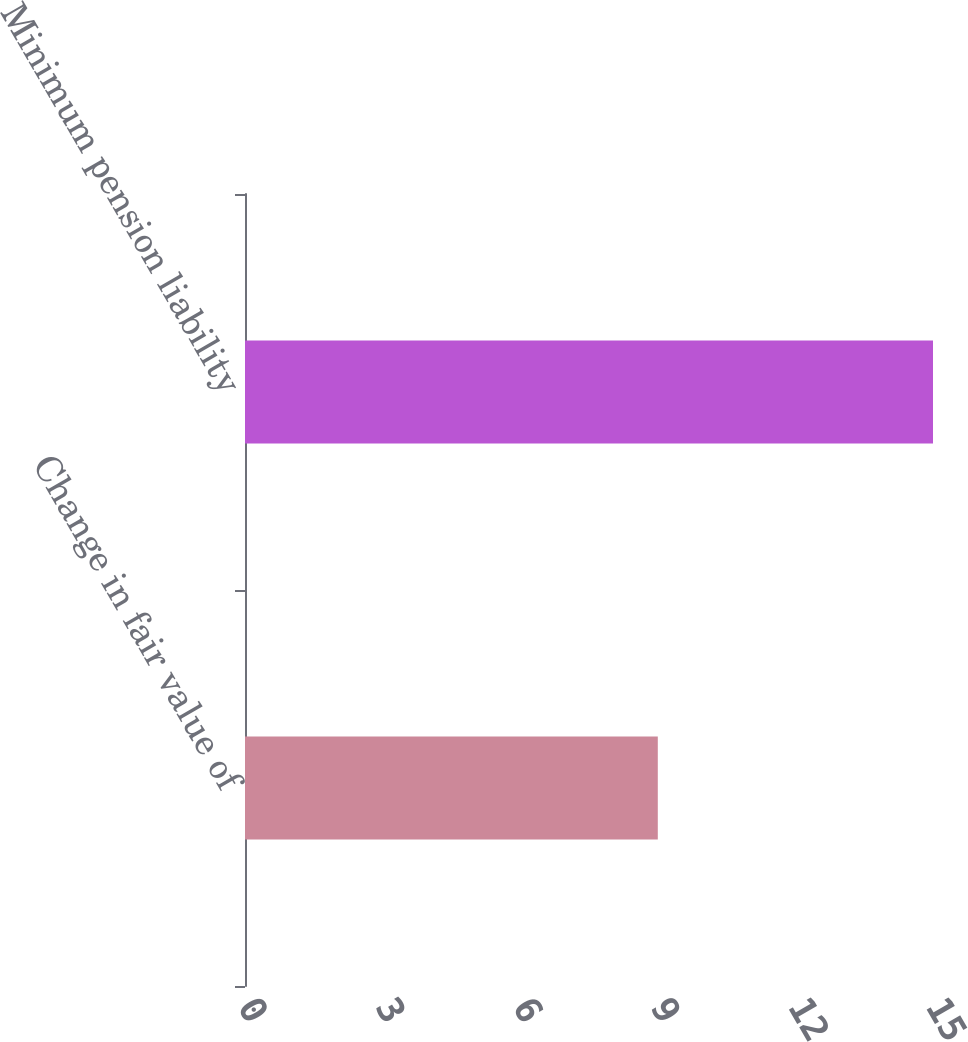<chart> <loc_0><loc_0><loc_500><loc_500><bar_chart><fcel>Change in fair value of<fcel>Minimum pension liability<nl><fcel>9<fcel>15<nl></chart> 